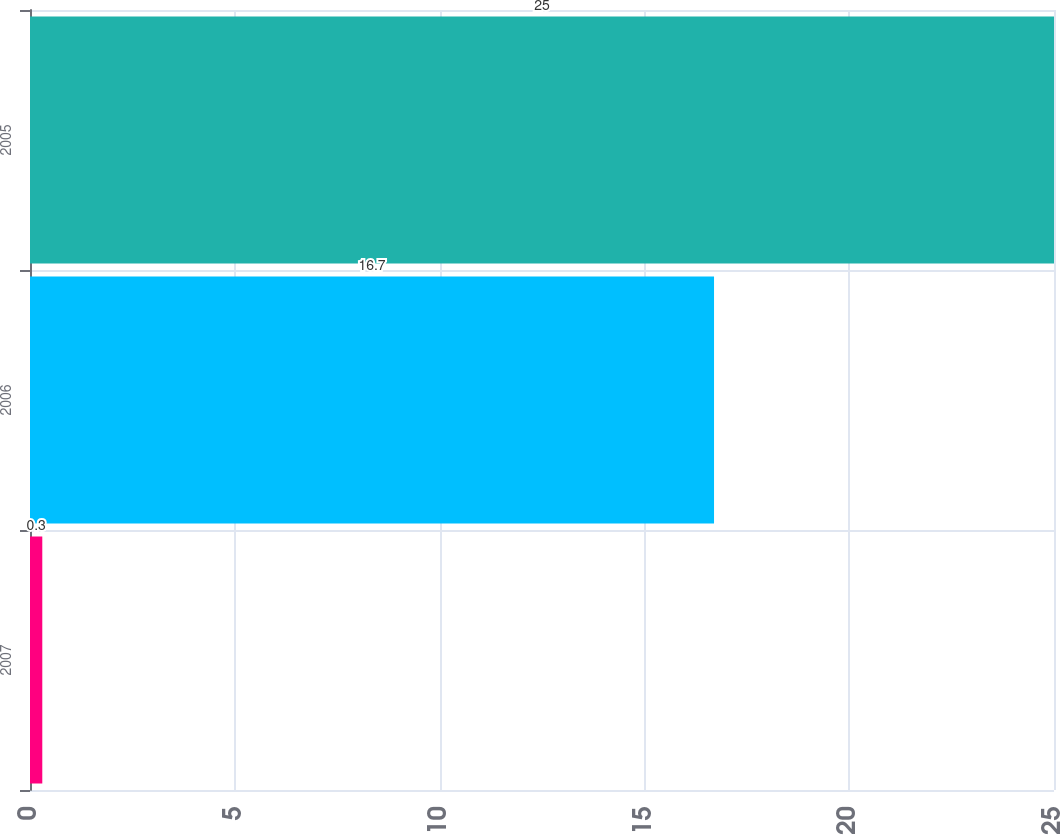<chart> <loc_0><loc_0><loc_500><loc_500><bar_chart><fcel>2007<fcel>2006<fcel>2005<nl><fcel>0.3<fcel>16.7<fcel>25<nl></chart> 